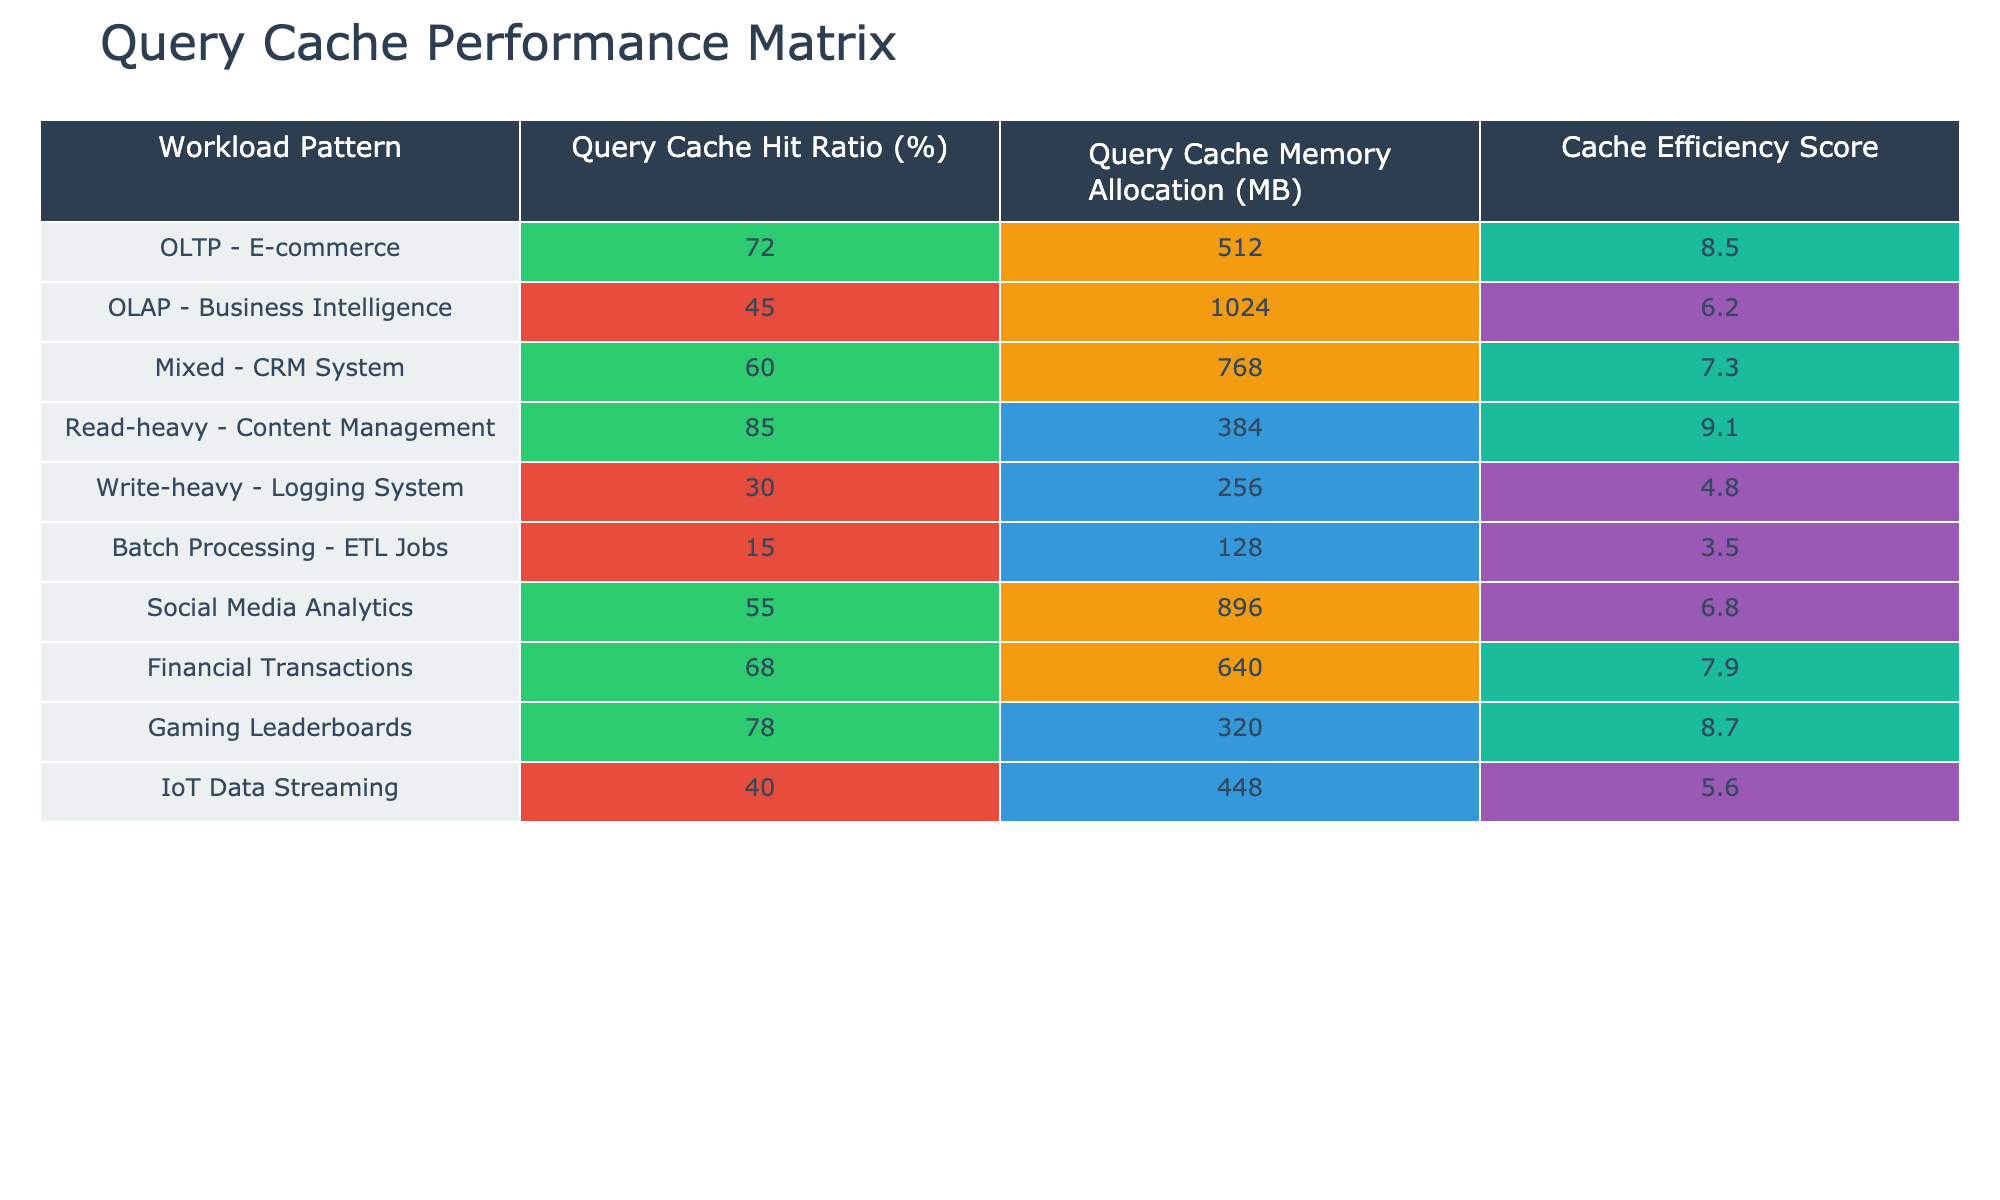What is the Query Cache Hit Ratio for a Read-heavy Content Management workload? The table shows that the Query Cache Hit Ratio for Read-heavy - Content Management is 85%.
Answer: 85% Which workload pattern has the highest Query Cache Memory Allocation? Looking at the table, the OLAP - Business Intelligence workload has the highest memory allocation at 1024 MB.
Answer: 1024 MB Is there any workload pattern with a Query Cache Hit Ratio below 50%? Yes, the Write-heavy - Logging System and Batch Processing - ETL Jobs both have Query Cache Hit Ratios below 50%.
Answer: Yes What is the average Cache Efficiency Score for all workload patterns? Adding all the Cache Efficiency Scores together gives 8.5 + 6.2 + 7.3 + 9.1 + 4.8 + 3.5 + 6.8 + 7.9 + 8.7 + 5.6 = 58.4. There are 10 workload patterns, so the average is 58.4 / 10 = 5.84.
Answer: 5.84 Which workload pattern has both a Query Cache Hit Ratio above 70% and a Cache Efficiency Score above 7? The Read-heavy - Content Management and Gaming Leaderboards patterns both satisfy these conditions, having hit ratios of 85% and 78%, and efficiency scores of 9.1 and 8.7 respectively.
Answer: Read-heavy - Content Management and Gaming Leaderboards How many workload patterns have a Cache Efficiency Score below 5? The table shows only the Batch Processing - ETL Jobs has a Cache Efficiency Score below 5, specifically at 3.5. Therefore, the count is 1.
Answer: 1 What is the Query Cache Hit Ratio difference between the OLTP - E-commerce and the Financial Transactions workloads? The Query Cache Hit Ratio for OLTP - E-commerce is 72%, while for Financial Transactions it is 68%. The difference is 72 - 68 = 4%.
Answer: 4% Which workload pattern has the lowest Query Cache Hit Ratio and what is that ratio? Batch Processing - ETL Jobs has the lowest Query Cache Hit Ratio at 15%.
Answer: 15% Does any workload with high Query Cache Hit Ratio also have a low Query Cache Memory Allocation? Yes, the Read-heavy - Content Management has a high Query Cache Hit Ratio of 85% and a memory allocation of 384 MB, which is relatively low compared to others.
Answer: Yes What is the Query Cache Memory Allocation for the Mixed - CRM System workload pattern? The table indicates that the Query Cache Memory Allocation for Mixed - CRM System is 768 MB.
Answer: 768 MB Identify the workload pattern with the second-highest Cache Efficiency Score. Ranking the Cache Efficiency Scores, the second highest is the Gaming Leaderboards at 8.7, after the Read-heavy - Content Management at 9.1.
Answer: Gaming Leaderboards 